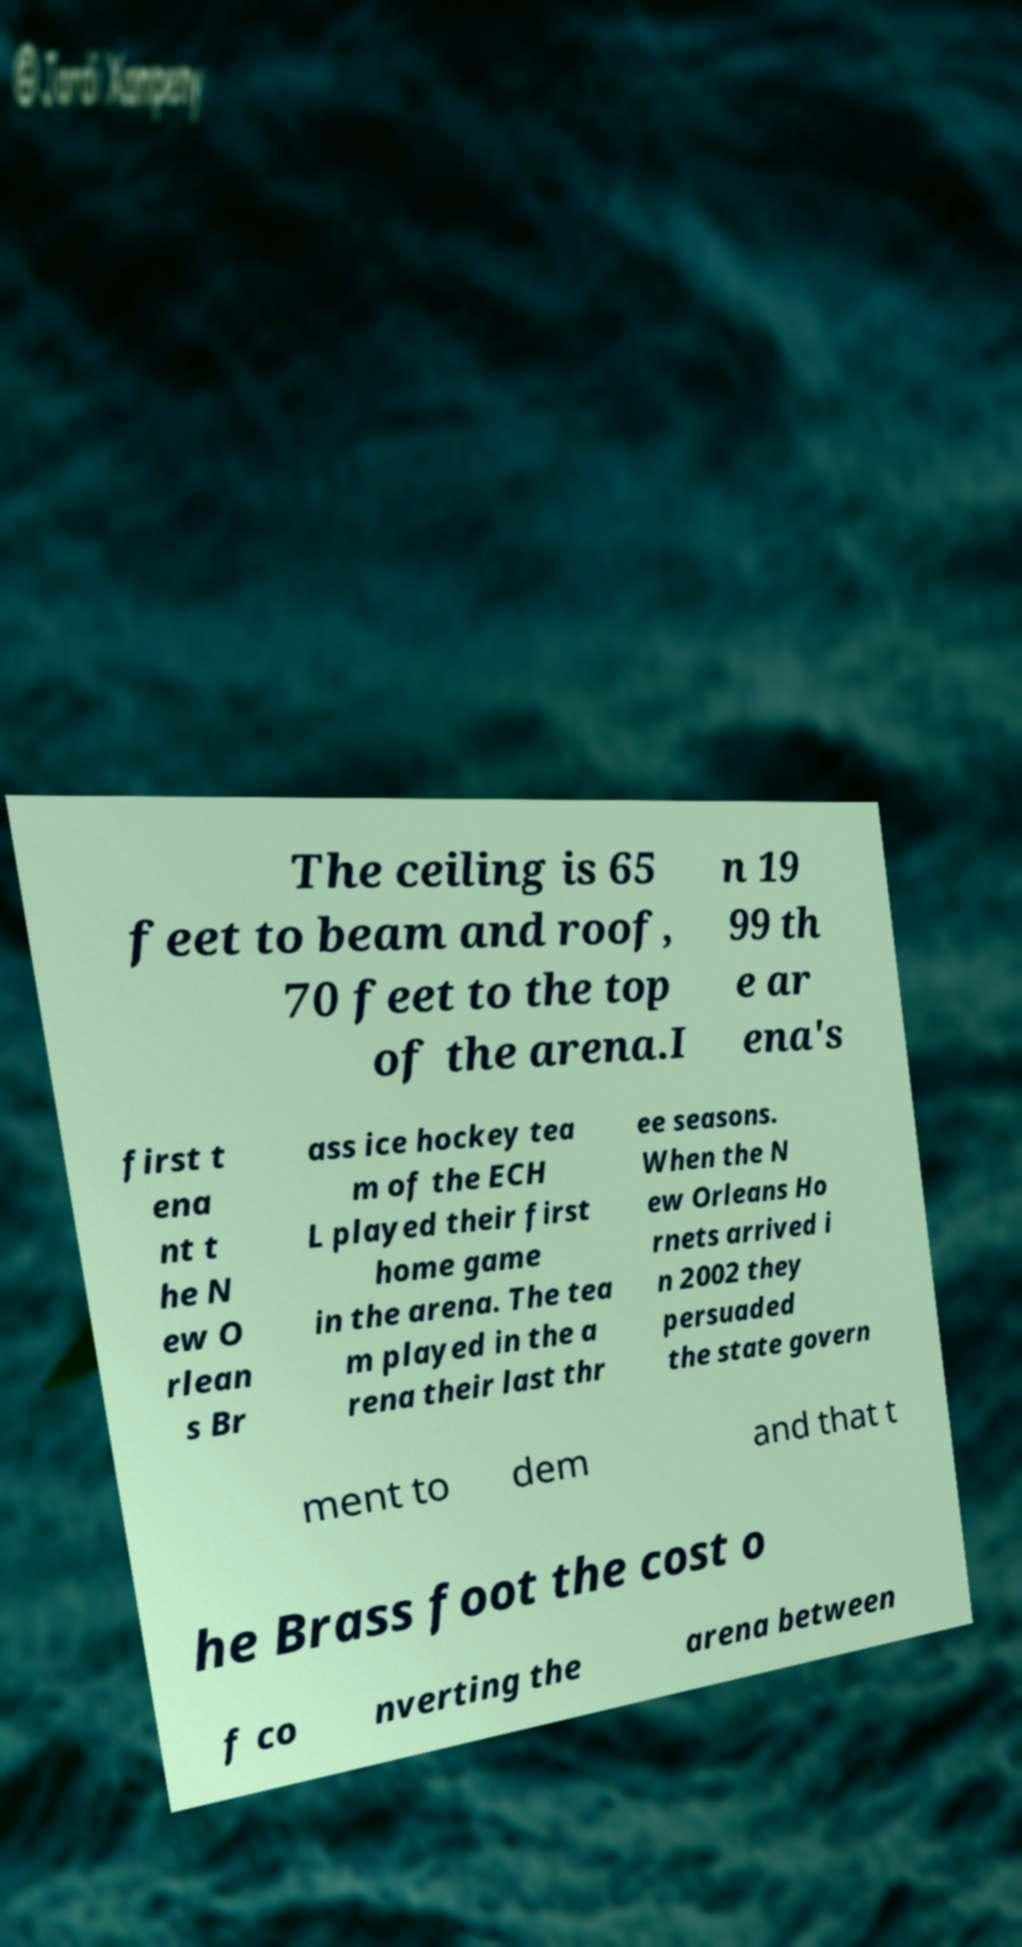Could you assist in decoding the text presented in this image and type it out clearly? The ceiling is 65 feet to beam and roof, 70 feet to the top of the arena.I n 19 99 th e ar ena's first t ena nt t he N ew O rlean s Br ass ice hockey tea m of the ECH L played their first home game in the arena. The tea m played in the a rena their last thr ee seasons. When the N ew Orleans Ho rnets arrived i n 2002 they persuaded the state govern ment to dem and that t he Brass foot the cost o f co nverting the arena between 